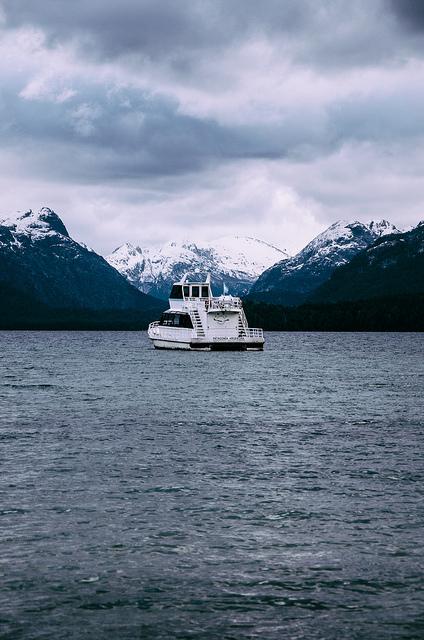Is the water likely cold here?
Quick response, please. Yes. Is the weather calm or very windy?
Concise answer only. Calm. Is there a wake behind the boat?
Quick response, please. No. How many boats in the photo?
Keep it brief. 1. Where would the people on the boat be able to find fresh water?
Keep it brief. Ocean. Is there a buoy in the water?
Give a very brief answer. No. What's the weather?
Be succinct. Cloudy. How many boats are there?
Answer briefly. 1. 